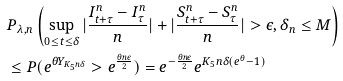<formula> <loc_0><loc_0><loc_500><loc_500>& P _ { \lambda , n } \left ( \sup _ { 0 \leq t \leq \delta } | \frac { I _ { t + \tau } ^ { n } - I _ { \tau } ^ { n } } { n } | + | \frac { S _ { t + \tau } ^ { n } - S _ { \tau } ^ { n } } { n } | > \epsilon , \delta _ { n } \leq M \right ) \\ & \leq P ( e ^ { \theta Y _ { K _ { 5 } n \delta } } > e ^ { \frac { \theta n \epsilon } { 2 } } ) = e ^ { - \frac { \theta n \epsilon } { 2 } } e ^ { K _ { 5 } n \delta ( e ^ { \theta } - 1 ) }</formula> 